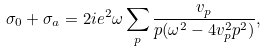Convert formula to latex. <formula><loc_0><loc_0><loc_500><loc_500>\sigma _ { 0 } + \sigma _ { a } = 2 i e ^ { 2 } \omega \sum _ { p } \frac { v _ { p } } { p ( \omega ^ { 2 } - 4 v _ { p } ^ { 2 } p ^ { 2 } ) } ,</formula> 